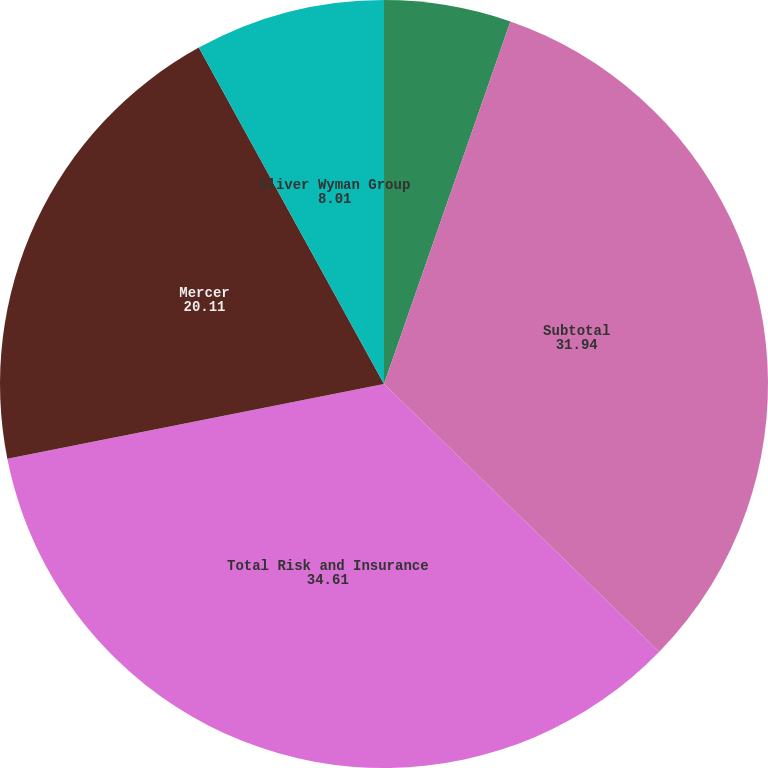Convert chart. <chart><loc_0><loc_0><loc_500><loc_500><pie_chart><fcel>Guy Carpenter<fcel>Subtotal<fcel>Total Risk and Insurance<fcel>Mercer<fcel>Oliver Wyman Group<nl><fcel>5.34%<fcel>31.94%<fcel>34.61%<fcel>20.11%<fcel>8.01%<nl></chart> 